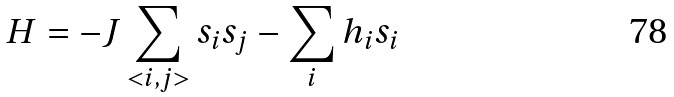<formula> <loc_0><loc_0><loc_500><loc_500>H = - J \sum _ { < i , j > } s _ { i } s _ { j } - \sum _ { i } h _ { i } s _ { i }</formula> 